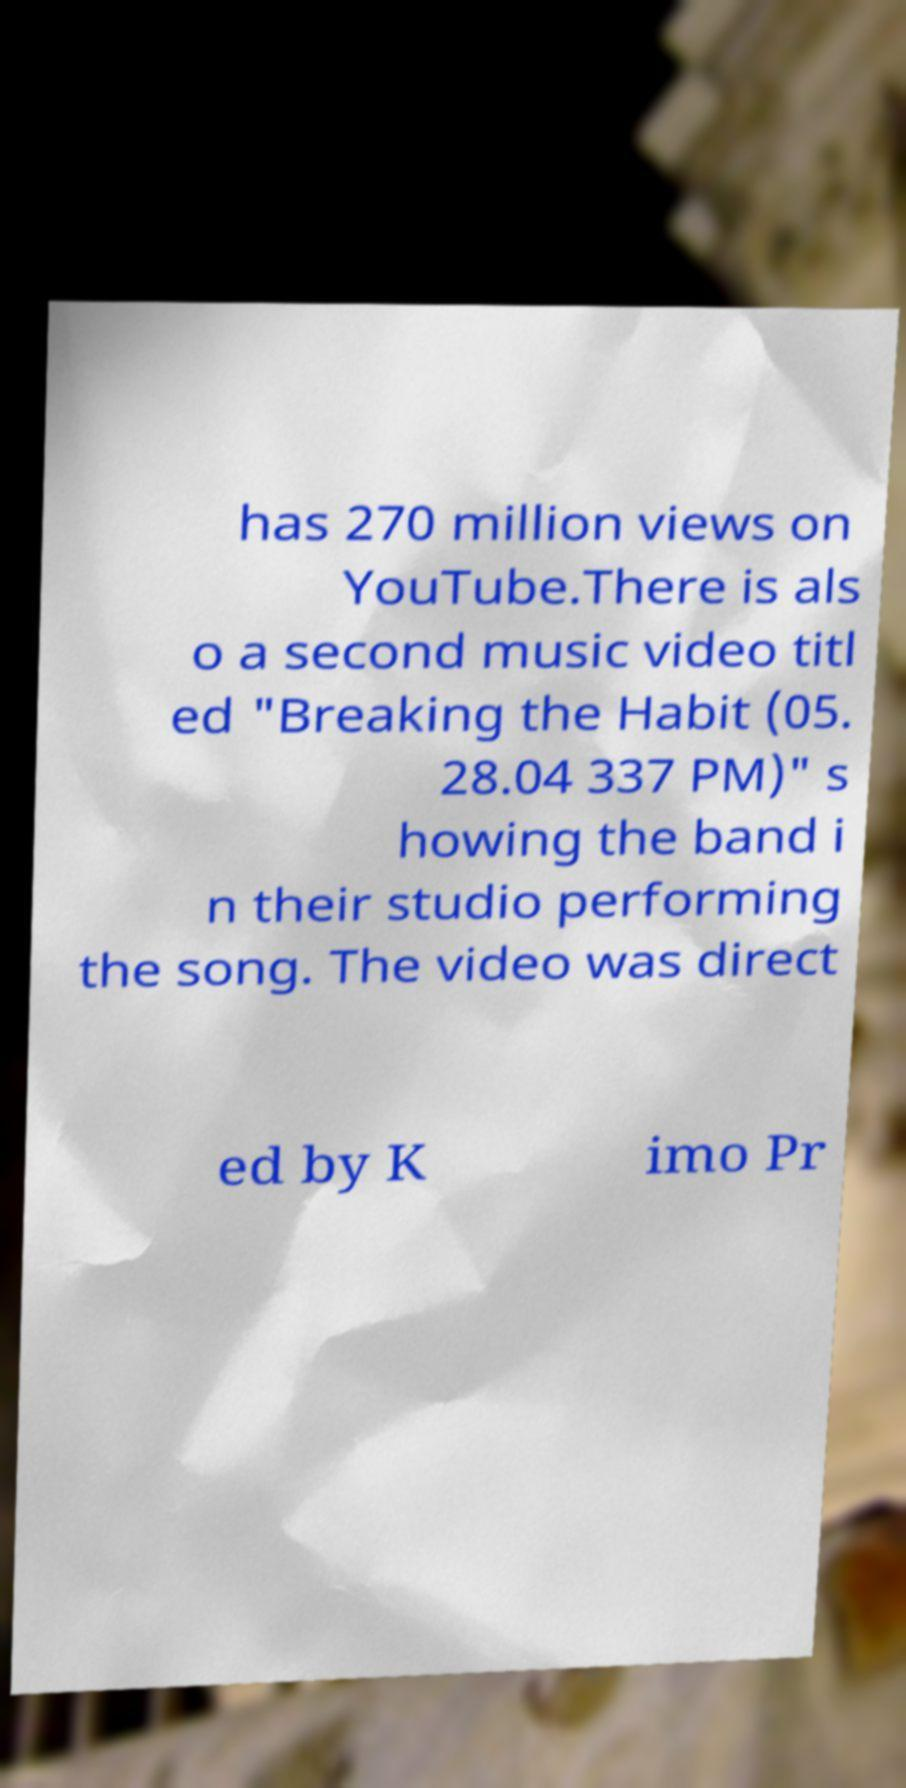I need the written content from this picture converted into text. Can you do that? has 270 million views on YouTube.There is als o a second music video titl ed "Breaking the Habit (05. 28.04 337 PM)" s howing the band i n their studio performing the song. The video was direct ed by K imo Pr 